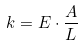<formula> <loc_0><loc_0><loc_500><loc_500>k = E \cdot { \frac { A } { L } }</formula> 